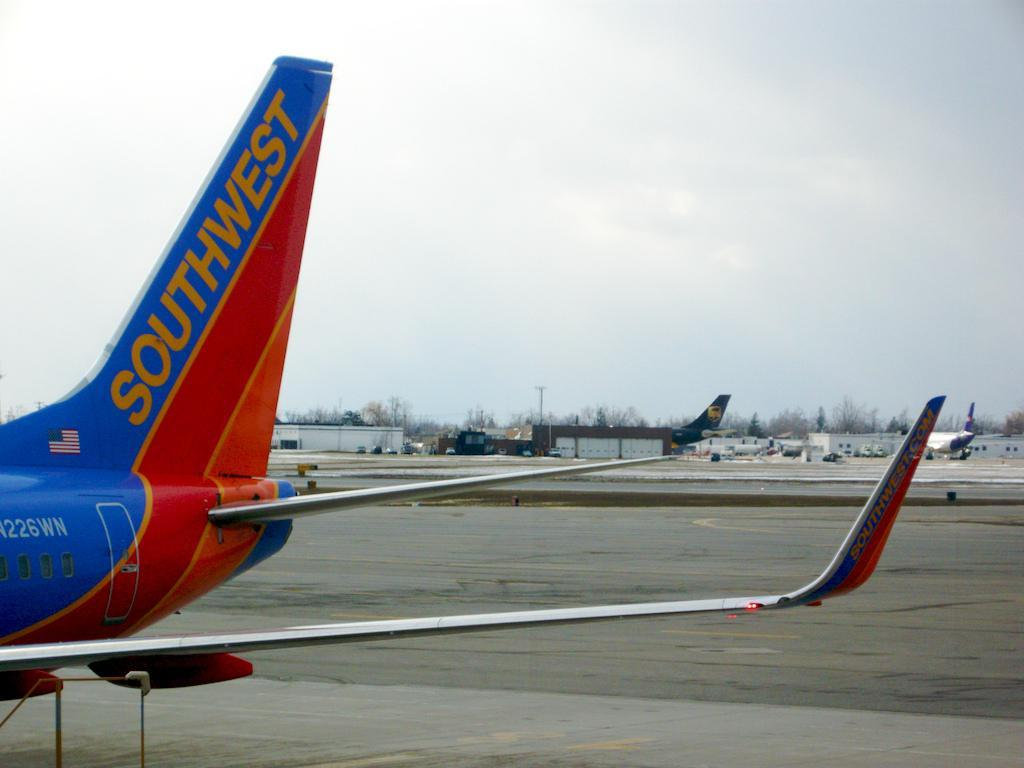<image>
Describe the image concisely. Rear wing of a Southwest jet is shown as it's parked on the tarmac. 